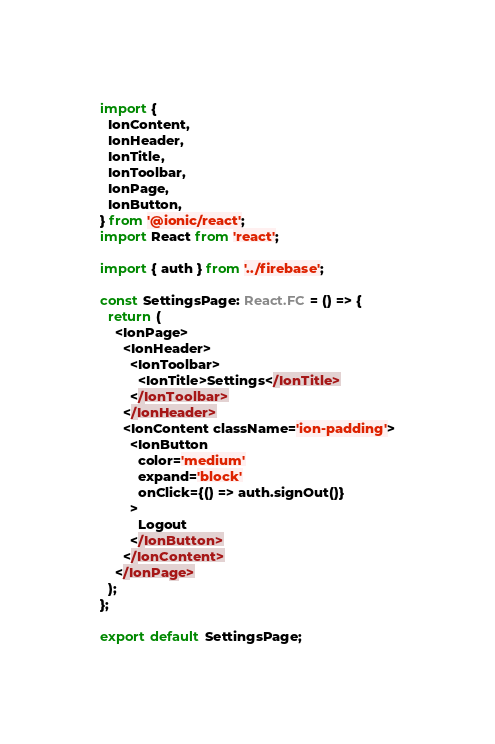Convert code to text. <code><loc_0><loc_0><loc_500><loc_500><_TypeScript_>import {
  IonContent,
  IonHeader,
  IonTitle,
  IonToolbar,
  IonPage,
  IonButton,
} from '@ionic/react';
import React from 'react';

import { auth } from '../firebase';

const SettingsPage: React.FC = () => {
  return (
    <IonPage>
      <IonHeader>
        <IonToolbar>
          <IonTitle>Settings</IonTitle>
        </IonToolbar>
      </IonHeader>
      <IonContent className='ion-padding'>
        <IonButton
          color='medium'
          expand='block'
          onClick={() => auth.signOut()}
        >
          Logout
        </IonButton>
      </IonContent>
    </IonPage>
  );
};

export default SettingsPage;
</code> 